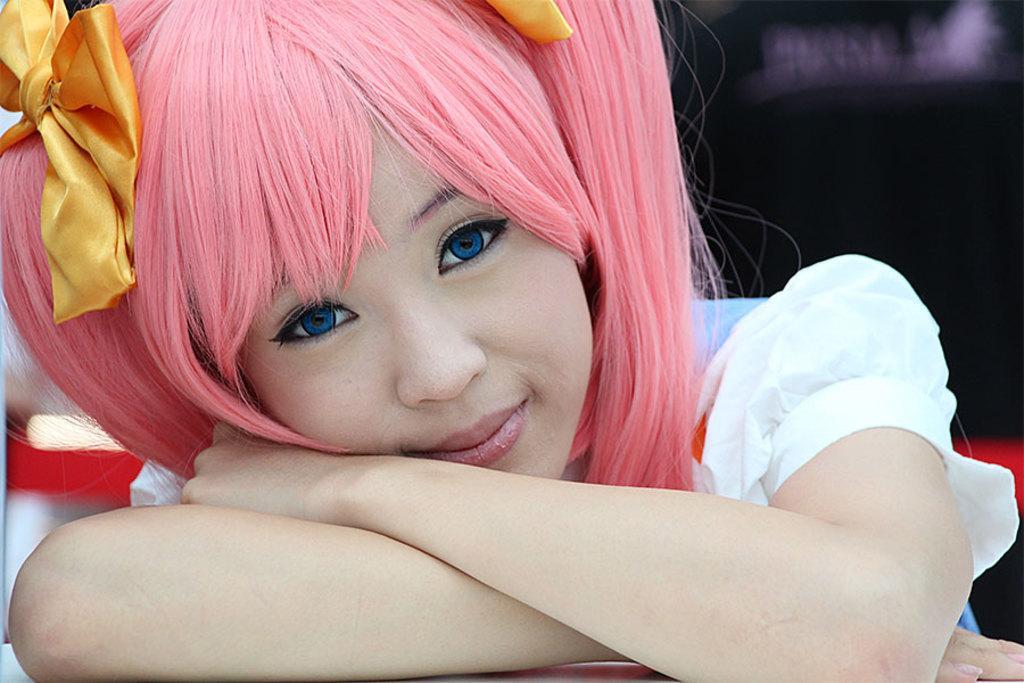Please provide a concise description of this image. In this picture there is a girl with white dress and blue eyes is smiling and she has pink hair. At the back the image is blurry. 